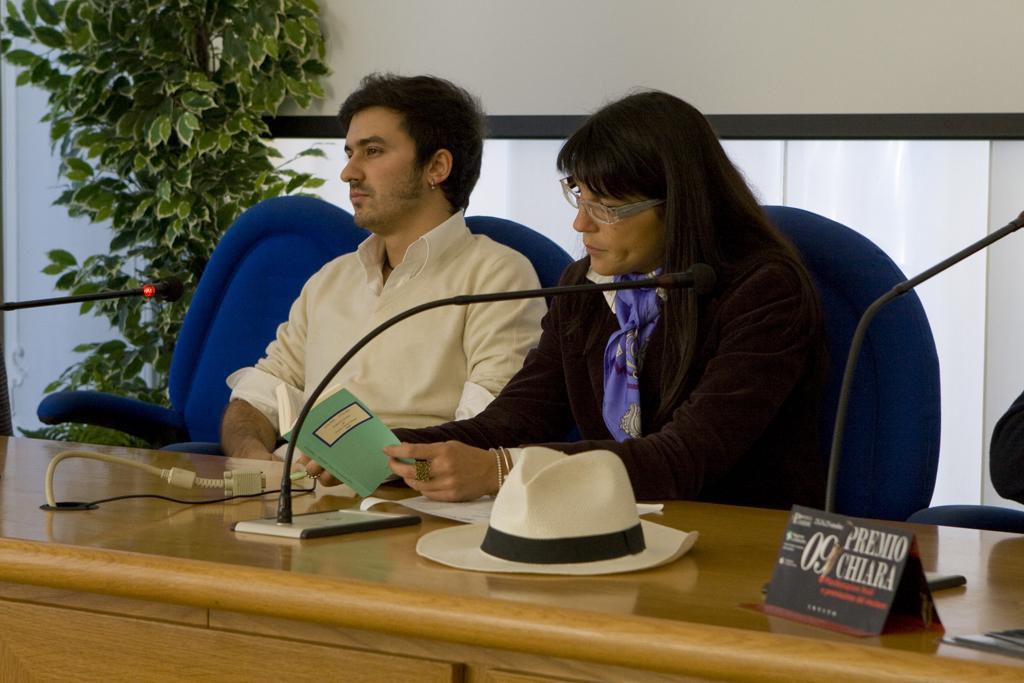How would you summarize this image in a sentence or two? In this picture we can see man and woman sitting on chair and here woman looking at book and in front of them there is table and on table we can see cap, mic, board, wires and in background we can see tree, wall. 